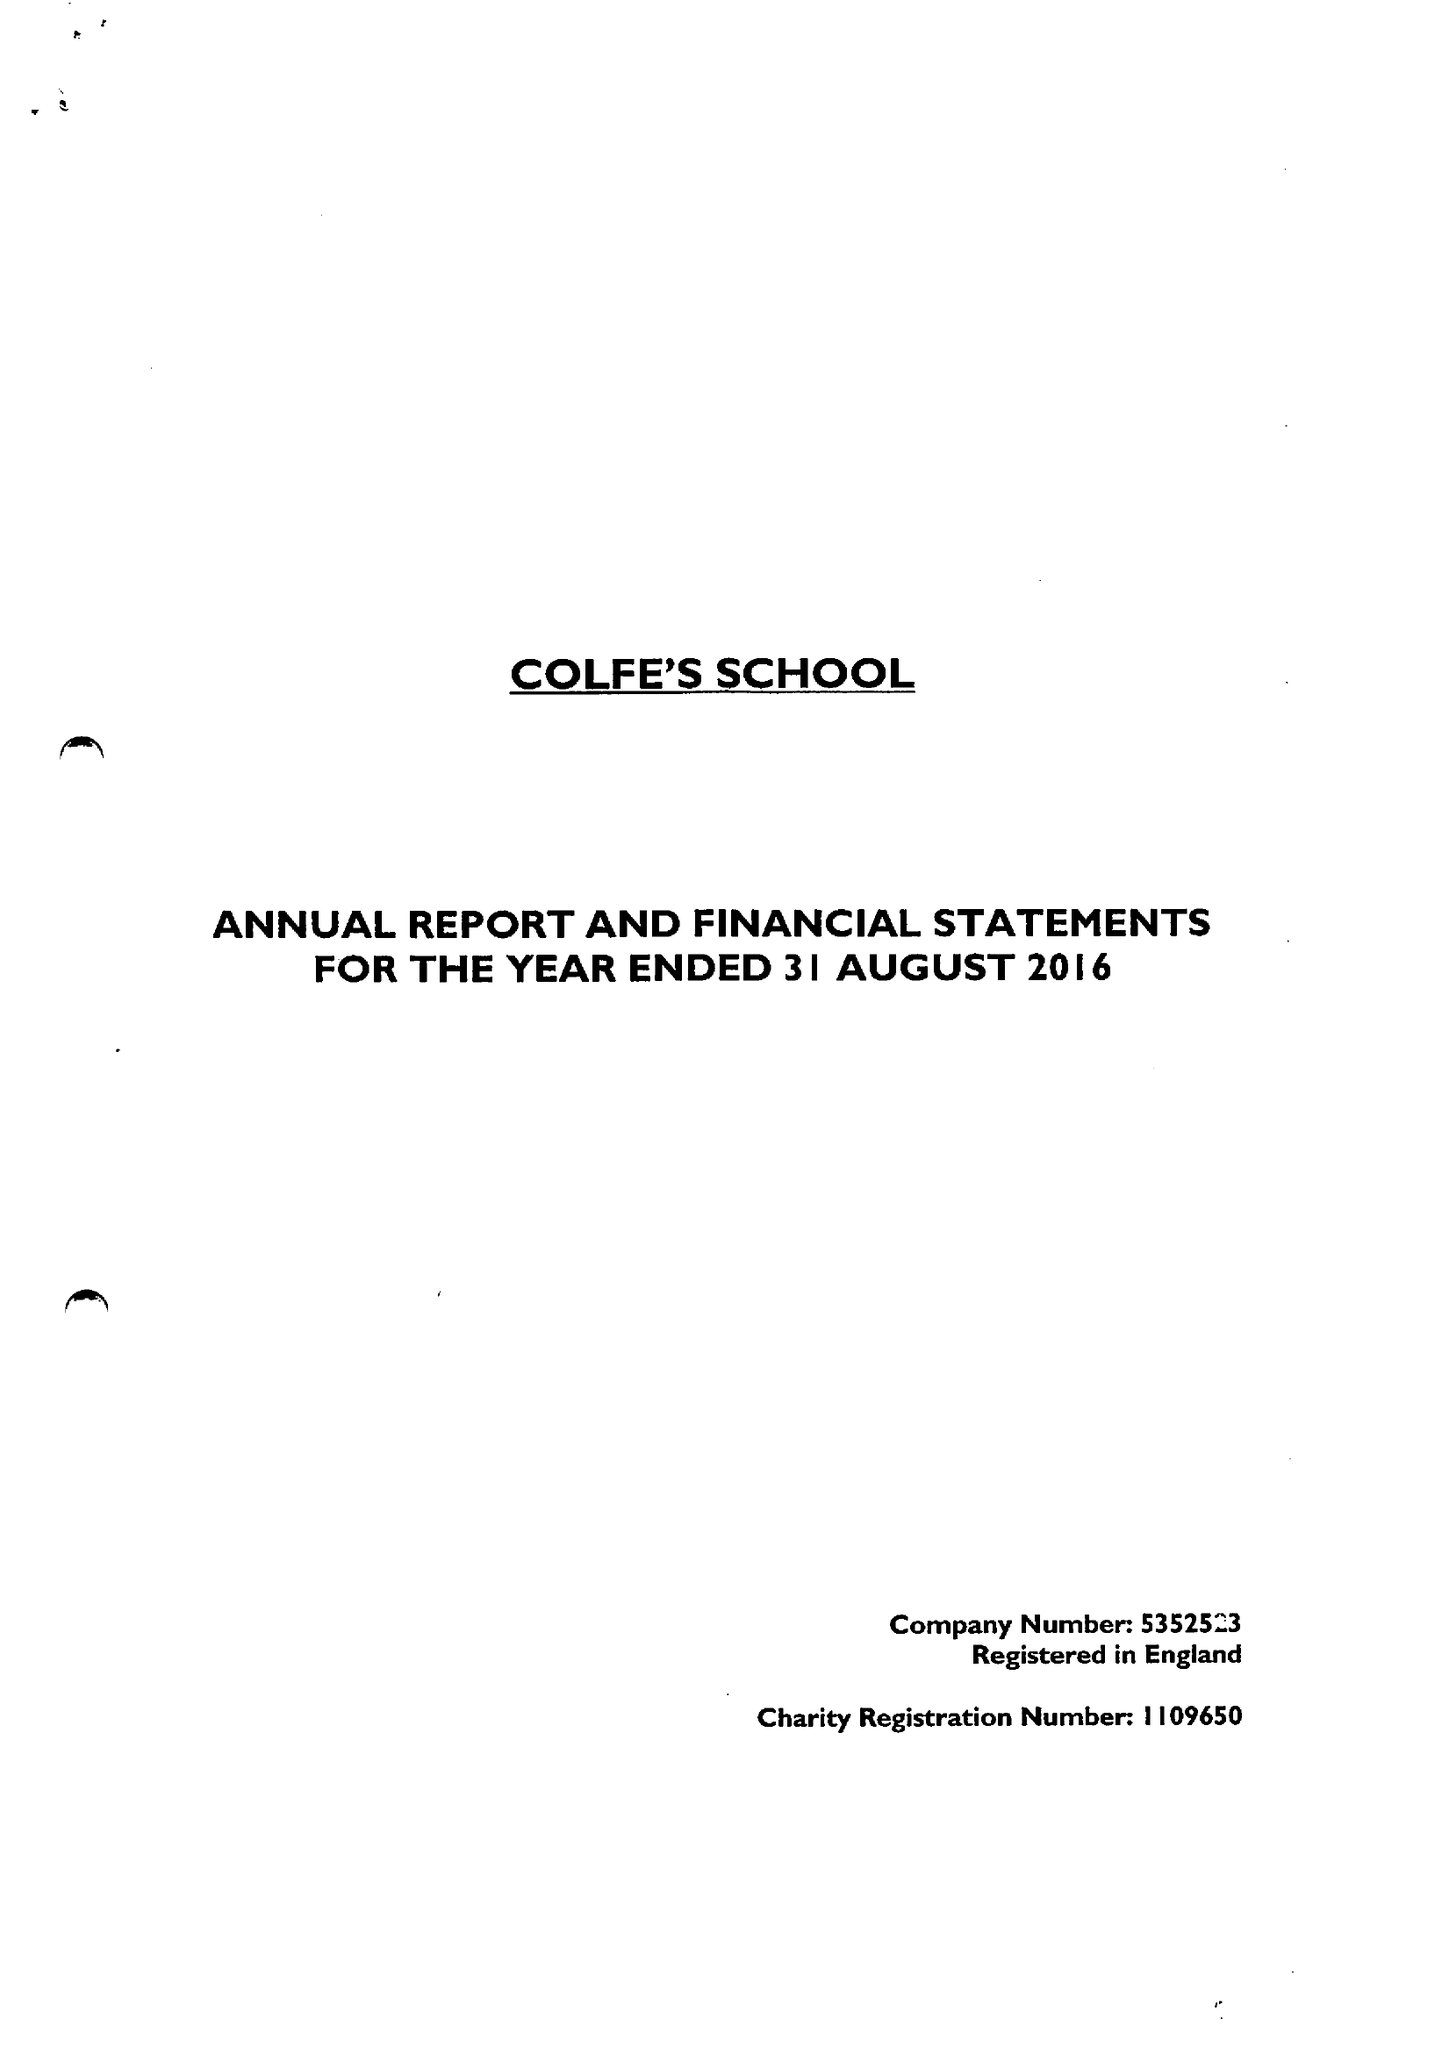What is the value for the charity_name?
Answer the question using a single word or phrase. Colfe's School 